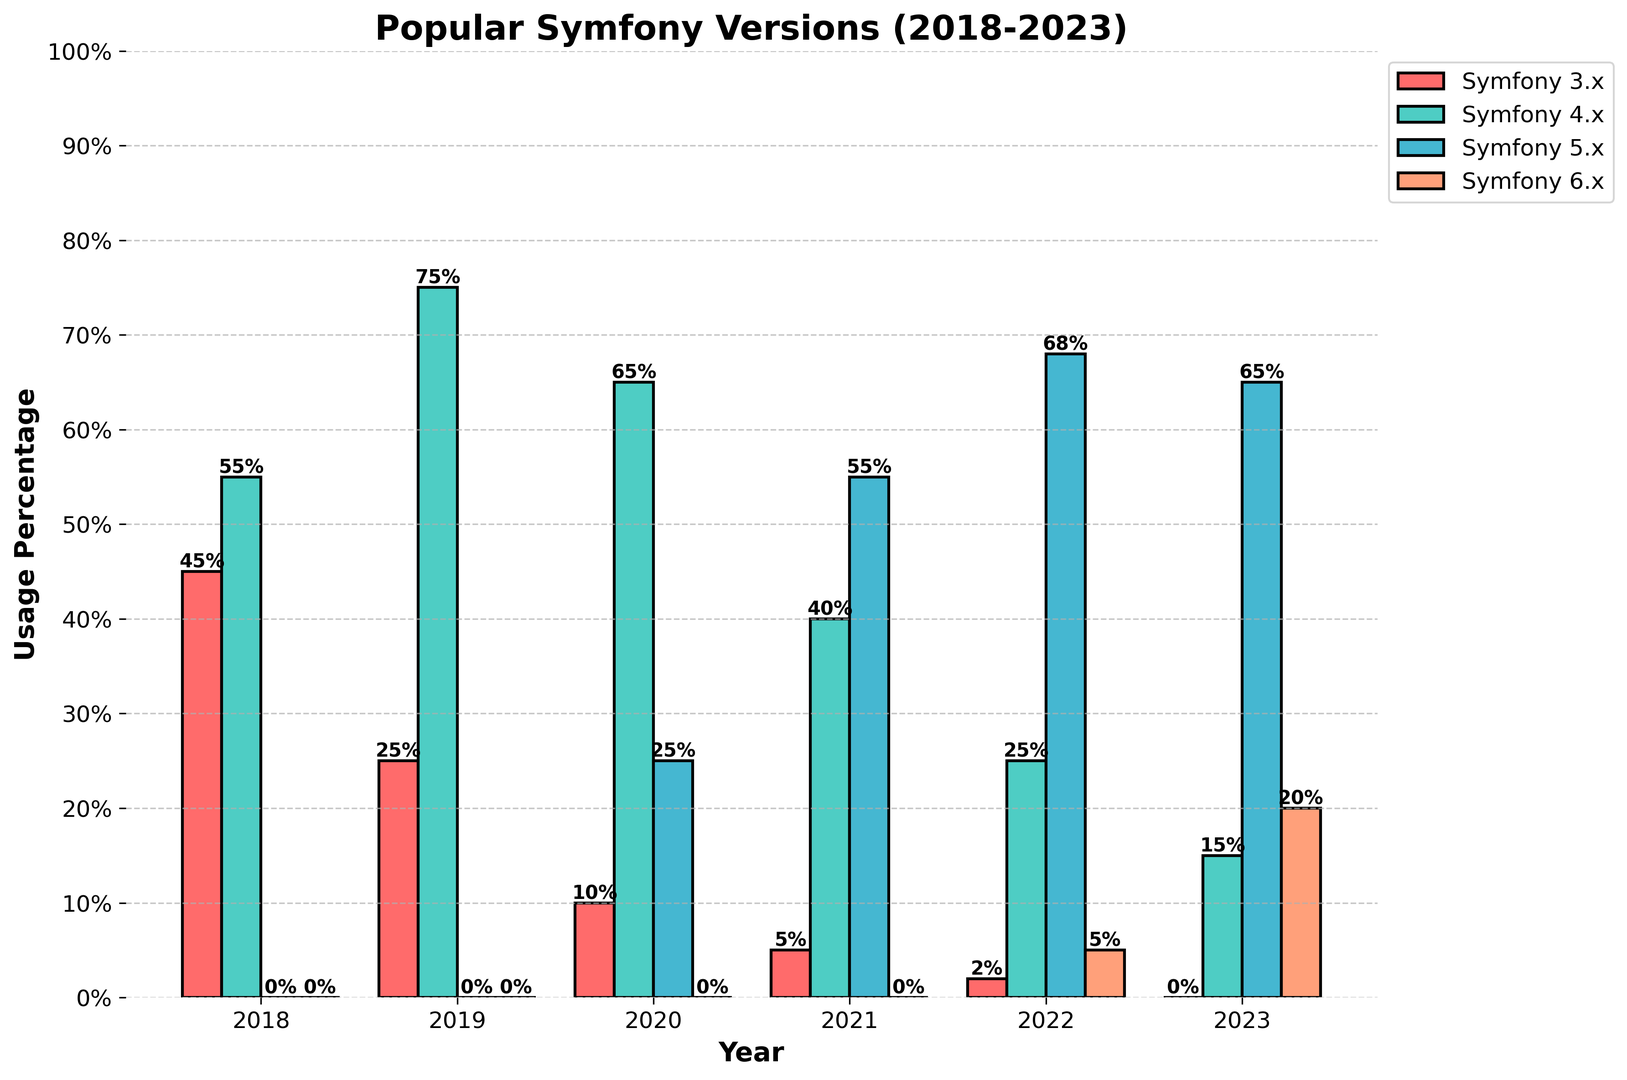Which Symfony version had the highest usage in 2021? To determine the highest usage percentage among the Symfony versions in 2021, look at the bars for that year and compare their heights. Symfony 5.x has the tallest bar in 2021 with 55% usage.
Answer: Symfony 5.x Which year did Symfony 4.x have its peak usage? Examine the bars corresponding to Symfony 4.x across all the years. The highest bar is in 2019 with 75% usage.
Answer: 2019 How did the usage of Symfony 3.x change from 2018 to 2020? To determine the change, subtract the percentage in 2020 from 2018: 45% (2018) - 10% (2020) = 35%. Symfony 3.x usage decreased by 35 percentage points from 2018 to 2020.
Answer: Decreased by 35% Compare the combined usage of Symfony 5.x and Symfony 6.x in 2023 to the combined usage of Symfony 4.x and Symfony 5.x in 2020. Which combination had higher usage? Calculate the combined percentages for both years: Symfony 5.x and Symfony 6.x in 2023: 65% + 20% = 85%. Symfony 4.x and Symfony 5.x in 2020: 65% + 25% = 90%. Thus, the latter combination in 2020 had higher usage.
Answer: Symfony 4.x and Symfony 5.x in 2020 What is the average usage percentage of Symfony 6.x over the years it appeared? Symfony 6.x appears in 2022 and 2023 with usage percentages of 5% and 20%. The average is calculated as (5% + 20%)/2 = 12.5%.
Answer: 12.5% Which year had the least diversity in Symfony version usage, indicating that one version dominated the others? Look for the year with the largest difference between the highest and lowest usage percentages. In 2019, Symfony 4.x had 75% usage, and other versions had low or zero usage, showing the least diversity.
Answer: 2019 What percentage increase in usage did Symfony 6.x experience from 2022 to 2023? Calculate the percentage increase: (20% - 5%)/5% * 100% = 300%. Symfony 6.x experienced a 300% increase in usage from 2022 to 2023.
Answer: 300% What is the total usage percentage of all Symfony versions combined in 2022? Sum the usage percentages of all versions for 2022: 2% (Symfony 3.x) + 25% (Symfony 4.x) + 68% (Symfony 5.x) + 5% (Symfony 6.x) = 100%.
Answer: 100% Which version showed a continuous increase in usage from its first appearance to the last recorded year? Analyze each version to determine if their usage steadily increased year by year. Symfony 5.x shows a continuous increase in usage from 2020 to 2022 (25% to 68%).
Answer: Symfony 5.x 